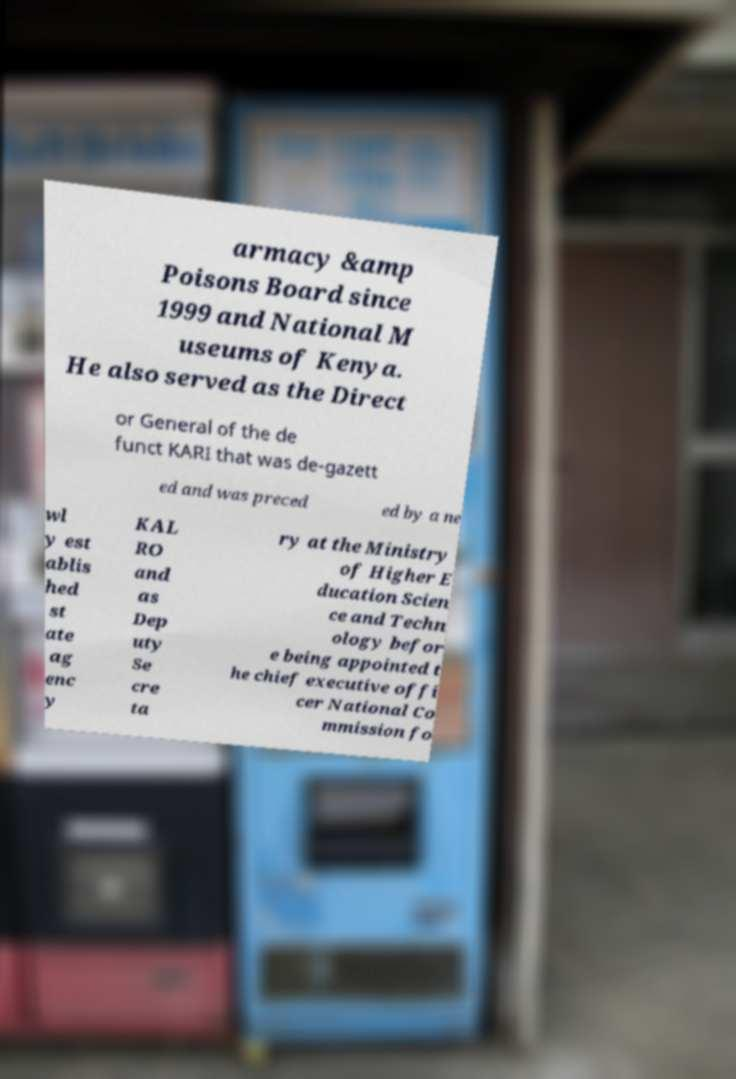I need the written content from this picture converted into text. Can you do that? armacy &amp Poisons Board since 1999 and National M useums of Kenya. He also served as the Direct or General of the de funct KARI that was de-gazett ed and was preced ed by a ne wl y est ablis hed st ate ag enc y KAL RO and as Dep uty Se cre ta ry at the Ministry of Higher E ducation Scien ce and Techn ology befor e being appointed t he chief executive offi cer National Co mmission fo 